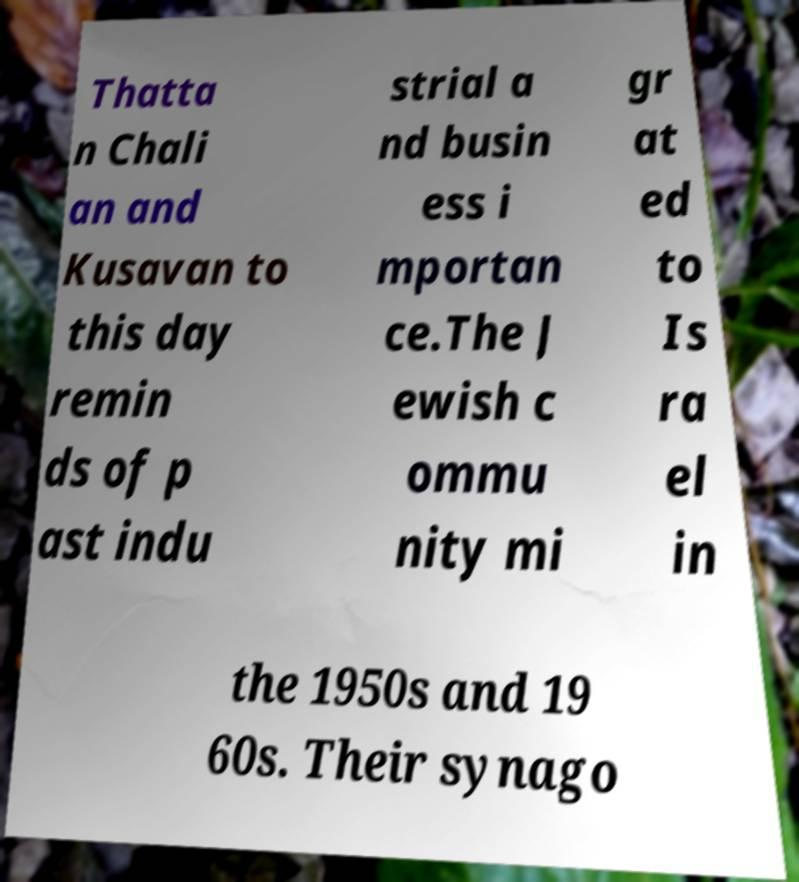Please read and relay the text visible in this image. What does it say? Thatta n Chali an and Kusavan to this day remin ds of p ast indu strial a nd busin ess i mportan ce.The J ewish c ommu nity mi gr at ed to Is ra el in the 1950s and 19 60s. Their synago 